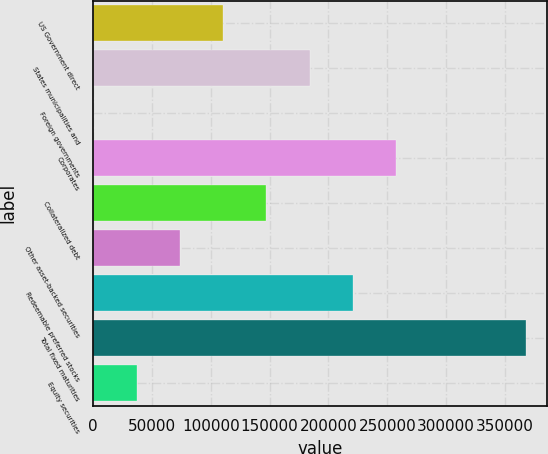<chart> <loc_0><loc_0><loc_500><loc_500><bar_chart><fcel>US Government direct<fcel>States municipalities and<fcel>Foreign governments<fcel>Corporates<fcel>Collateralized debt<fcel>Other asset-backed securities<fcel>Redeemable preferred stocks<fcel>Total fixed maturities<fcel>Equity securities<nl><fcel>110322<fcel>183868<fcel>4.12<fcel>257414<fcel>147095<fcel>73549.7<fcel>220641<fcel>367732<fcel>36776.9<nl></chart> 